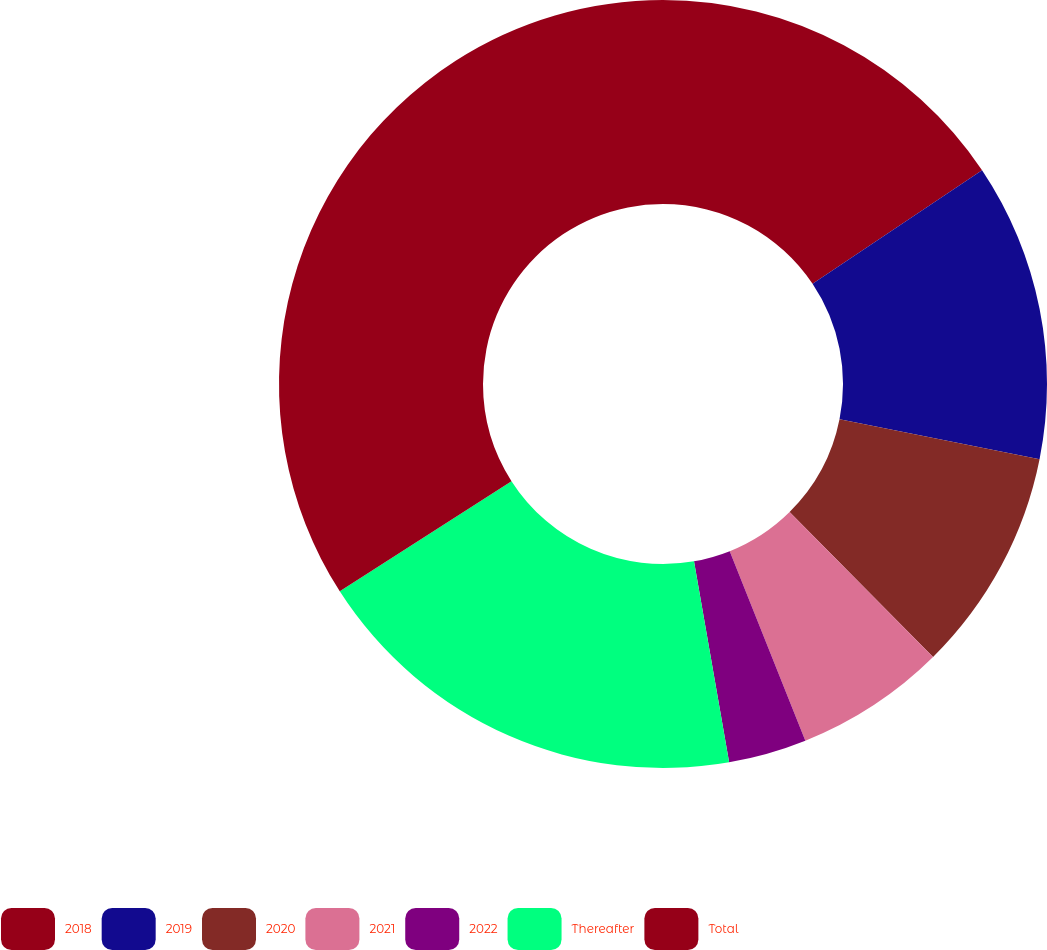<chart> <loc_0><loc_0><loc_500><loc_500><pie_chart><fcel>2018<fcel>2019<fcel>2020<fcel>2021<fcel>2022<fcel>Thereafter<fcel>Total<nl><fcel>15.61%<fcel>12.53%<fcel>9.45%<fcel>6.37%<fcel>3.29%<fcel>18.68%<fcel>34.08%<nl></chart> 